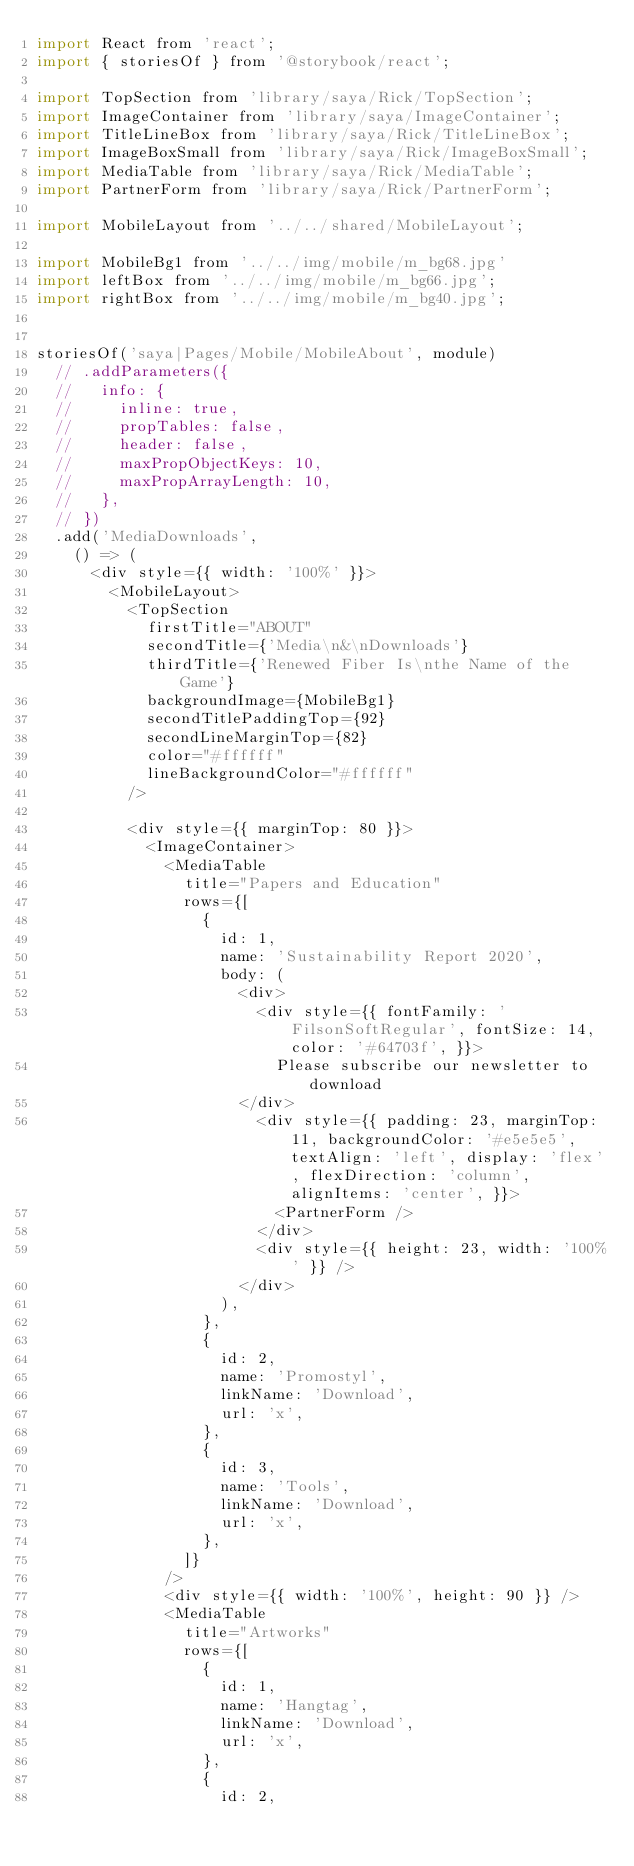<code> <loc_0><loc_0><loc_500><loc_500><_JavaScript_>import React from 'react';
import { storiesOf } from '@storybook/react';

import TopSection from 'library/saya/Rick/TopSection';
import ImageContainer from 'library/saya/ImageContainer';
import TitleLineBox from 'library/saya/Rick/TitleLineBox';
import ImageBoxSmall from 'library/saya/Rick/ImageBoxSmall';
import MediaTable from 'library/saya/Rick/MediaTable';
import PartnerForm from 'library/saya/Rick/PartnerForm';

import MobileLayout from '../../shared/MobileLayout';

import MobileBg1 from '../../img/mobile/m_bg68.jpg'
import leftBox from '../../img/mobile/m_bg66.jpg';
import rightBox from '../../img/mobile/m_bg40.jpg';


storiesOf('saya|Pages/Mobile/MobileAbout', module)
  // .addParameters({
  //   info: {
  //     inline: true,
  //     propTables: false,
  //     header: false,
  //     maxPropObjectKeys: 10,
  //     maxPropArrayLength: 10,
  //   },
  // })
  .add('MediaDownloads',
    () => (
      <div style={{ width: '100%' }}>
        <MobileLayout>
          <TopSection
            firstTitle="ABOUT"
            secondTitle={'Media\n&\nDownloads'}
            thirdTitle={'Renewed Fiber Is\nthe Name of the Game'}
            backgroundImage={MobileBg1}
            secondTitlePaddingTop={92}
            secondLineMarginTop={82}
            color="#ffffff"
            lineBackgroundColor="#ffffff"
          />

          <div style={{ marginTop: 80 }}>
            <ImageContainer>
              <MediaTable
                title="Papers and Education"
                rows={[
                  {
                    id: 1,
                    name: 'Sustainability Report 2020',
                    body: (
                      <div>
                        <div style={{ fontFamily: 'FilsonSoftRegular', fontSize: 14, color: '#64703f', }}>
                          Please subscribe our newsletter to download
                      </div>
                        <div style={{ padding: 23, marginTop: 11, backgroundColor: '#e5e5e5', textAlign: 'left', display: 'flex', flexDirection: 'column', alignItems: 'center', }}>
                          <PartnerForm />
                        </div>
                        <div style={{ height: 23, width: '100%' }} />
                      </div>
                    ),
                  },
                  {
                    id: 2,
                    name: 'Promostyl',
                    linkName: 'Download',
                    url: 'x',
                  },
                  {
                    id: 3,
                    name: 'Tools',
                    linkName: 'Download',
                    url: 'x',
                  },
                ]}
              />
              <div style={{ width: '100%', height: 90 }} />
              <MediaTable
                title="Artworks"
                rows={[
                  {
                    id: 1,
                    name: 'Hangtag',
                    linkName: 'Download',
                    url: 'x',
                  },
                  {
                    id: 2,</code> 